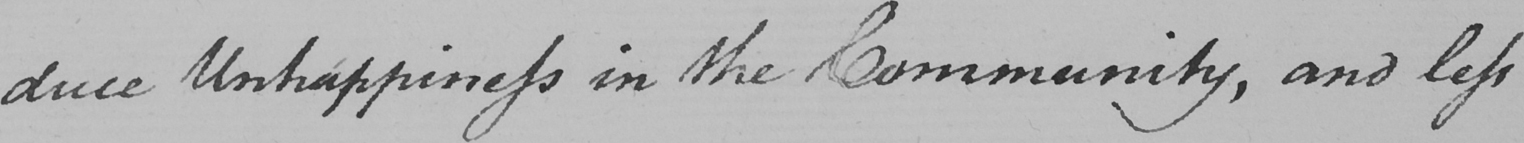Can you read and transcribe this handwriting? -duce Unhappiness in the Community , and less 